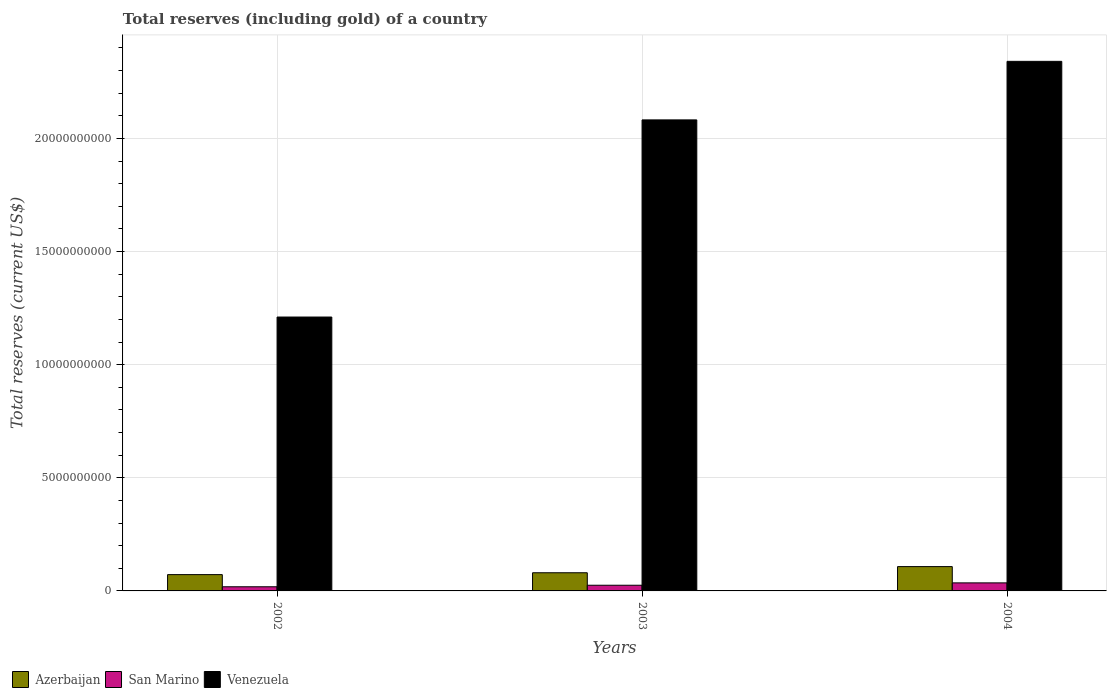How many different coloured bars are there?
Your answer should be very brief. 3. How many groups of bars are there?
Offer a very short reply. 3. Are the number of bars on each tick of the X-axis equal?
Your answer should be compact. Yes. How many bars are there on the 1st tick from the left?
Provide a succinct answer. 3. How many bars are there on the 2nd tick from the right?
Your response must be concise. 3. What is the label of the 3rd group of bars from the left?
Provide a short and direct response. 2004. What is the total reserves (including gold) in Venezuela in 2004?
Your answer should be compact. 2.34e+1. Across all years, what is the maximum total reserves (including gold) in San Marino?
Ensure brevity in your answer.  3.56e+08. Across all years, what is the minimum total reserves (including gold) in Venezuela?
Offer a terse response. 1.21e+1. What is the total total reserves (including gold) in Azerbaijan in the graph?
Provide a succinct answer. 2.60e+09. What is the difference between the total reserves (including gold) in Venezuela in 2002 and that in 2004?
Provide a short and direct response. -1.13e+1. What is the difference between the total reserves (including gold) in Azerbaijan in 2003 and the total reserves (including gold) in San Marino in 2002?
Your answer should be very brief. 6.19e+08. What is the average total reserves (including gold) in San Marino per year?
Offer a terse response. 2.63e+08. In the year 2003, what is the difference between the total reserves (including gold) in Azerbaijan and total reserves (including gold) in Venezuela?
Ensure brevity in your answer.  -2.00e+1. In how many years, is the total reserves (including gold) in Azerbaijan greater than 22000000000 US$?
Keep it short and to the point. 0. What is the ratio of the total reserves (including gold) in San Marino in 2003 to that in 2004?
Keep it short and to the point. 0.71. Is the total reserves (including gold) in Venezuela in 2002 less than that in 2004?
Ensure brevity in your answer.  Yes. Is the difference between the total reserves (including gold) in Azerbaijan in 2002 and 2003 greater than the difference between the total reserves (including gold) in Venezuela in 2002 and 2003?
Offer a very short reply. Yes. What is the difference between the highest and the second highest total reserves (including gold) in Venezuela?
Provide a succinct answer. 2.59e+09. What is the difference between the highest and the lowest total reserves (including gold) in Azerbaijan?
Your answer should be compact. 3.55e+08. In how many years, is the total reserves (including gold) in Venezuela greater than the average total reserves (including gold) in Venezuela taken over all years?
Offer a very short reply. 2. What does the 3rd bar from the left in 2002 represents?
Offer a very short reply. Venezuela. What does the 3rd bar from the right in 2002 represents?
Your answer should be very brief. Azerbaijan. Is it the case that in every year, the sum of the total reserves (including gold) in San Marino and total reserves (including gold) in Azerbaijan is greater than the total reserves (including gold) in Venezuela?
Your answer should be very brief. No. Are all the bars in the graph horizontal?
Provide a short and direct response. No. Are the values on the major ticks of Y-axis written in scientific E-notation?
Ensure brevity in your answer.  No. Does the graph contain any zero values?
Offer a terse response. No. How are the legend labels stacked?
Keep it short and to the point. Horizontal. What is the title of the graph?
Offer a very short reply. Total reserves (including gold) of a country. Does "Japan" appear as one of the legend labels in the graph?
Offer a very short reply. No. What is the label or title of the Y-axis?
Offer a terse response. Total reserves (current US$). What is the Total reserves (current US$) of Azerbaijan in 2002?
Provide a succinct answer. 7.20e+08. What is the Total reserves (current US$) of San Marino in 2002?
Your response must be concise. 1.83e+08. What is the Total reserves (current US$) in Venezuela in 2002?
Provide a succinct answer. 1.21e+1. What is the Total reserves (current US$) in Azerbaijan in 2003?
Offer a very short reply. 8.03e+08. What is the Total reserves (current US$) of San Marino in 2003?
Your answer should be very brief. 2.51e+08. What is the Total reserves (current US$) of Venezuela in 2003?
Your answer should be very brief. 2.08e+1. What is the Total reserves (current US$) in Azerbaijan in 2004?
Offer a very short reply. 1.08e+09. What is the Total reserves (current US$) in San Marino in 2004?
Make the answer very short. 3.56e+08. What is the Total reserves (current US$) in Venezuela in 2004?
Make the answer very short. 2.34e+1. Across all years, what is the maximum Total reserves (current US$) of Azerbaijan?
Keep it short and to the point. 1.08e+09. Across all years, what is the maximum Total reserves (current US$) in San Marino?
Provide a short and direct response. 3.56e+08. Across all years, what is the maximum Total reserves (current US$) of Venezuela?
Offer a very short reply. 2.34e+1. Across all years, what is the minimum Total reserves (current US$) in Azerbaijan?
Give a very brief answer. 7.20e+08. Across all years, what is the minimum Total reserves (current US$) of San Marino?
Your answer should be very brief. 1.83e+08. Across all years, what is the minimum Total reserves (current US$) of Venezuela?
Provide a succinct answer. 1.21e+1. What is the total Total reserves (current US$) of Azerbaijan in the graph?
Provide a short and direct response. 2.60e+09. What is the total Total reserves (current US$) in San Marino in the graph?
Your response must be concise. 7.90e+08. What is the total Total reserves (current US$) of Venezuela in the graph?
Your answer should be compact. 5.63e+1. What is the difference between the Total reserves (current US$) in Azerbaijan in 2002 and that in 2003?
Offer a very short reply. -8.24e+07. What is the difference between the Total reserves (current US$) in San Marino in 2002 and that in 2003?
Keep it short and to the point. -6.79e+07. What is the difference between the Total reserves (current US$) of Venezuela in 2002 and that in 2003?
Your answer should be compact. -8.71e+09. What is the difference between the Total reserves (current US$) in Azerbaijan in 2002 and that in 2004?
Provide a short and direct response. -3.55e+08. What is the difference between the Total reserves (current US$) in San Marino in 2002 and that in 2004?
Your response must be concise. -1.72e+08. What is the difference between the Total reserves (current US$) of Venezuela in 2002 and that in 2004?
Offer a terse response. -1.13e+1. What is the difference between the Total reserves (current US$) in Azerbaijan in 2003 and that in 2004?
Ensure brevity in your answer.  -2.72e+08. What is the difference between the Total reserves (current US$) of San Marino in 2003 and that in 2004?
Your answer should be very brief. -1.04e+08. What is the difference between the Total reserves (current US$) in Venezuela in 2003 and that in 2004?
Make the answer very short. -2.59e+09. What is the difference between the Total reserves (current US$) in Azerbaijan in 2002 and the Total reserves (current US$) in San Marino in 2003?
Ensure brevity in your answer.  4.69e+08. What is the difference between the Total reserves (current US$) of Azerbaijan in 2002 and the Total reserves (current US$) of Venezuela in 2003?
Your response must be concise. -2.01e+1. What is the difference between the Total reserves (current US$) of San Marino in 2002 and the Total reserves (current US$) of Venezuela in 2003?
Give a very brief answer. -2.06e+1. What is the difference between the Total reserves (current US$) of Azerbaijan in 2002 and the Total reserves (current US$) of San Marino in 2004?
Keep it short and to the point. 3.65e+08. What is the difference between the Total reserves (current US$) in Azerbaijan in 2002 and the Total reserves (current US$) in Venezuela in 2004?
Offer a very short reply. -2.27e+1. What is the difference between the Total reserves (current US$) in San Marino in 2002 and the Total reserves (current US$) in Venezuela in 2004?
Offer a very short reply. -2.32e+1. What is the difference between the Total reserves (current US$) in Azerbaijan in 2003 and the Total reserves (current US$) in San Marino in 2004?
Keep it short and to the point. 4.47e+08. What is the difference between the Total reserves (current US$) of Azerbaijan in 2003 and the Total reserves (current US$) of Venezuela in 2004?
Provide a short and direct response. -2.26e+1. What is the difference between the Total reserves (current US$) of San Marino in 2003 and the Total reserves (current US$) of Venezuela in 2004?
Offer a very short reply. -2.32e+1. What is the average Total reserves (current US$) in Azerbaijan per year?
Keep it short and to the point. 8.66e+08. What is the average Total reserves (current US$) of San Marino per year?
Offer a very short reply. 2.63e+08. What is the average Total reserves (current US$) of Venezuela per year?
Your answer should be very brief. 1.88e+1. In the year 2002, what is the difference between the Total reserves (current US$) in Azerbaijan and Total reserves (current US$) in San Marino?
Offer a very short reply. 5.37e+08. In the year 2002, what is the difference between the Total reserves (current US$) of Azerbaijan and Total reserves (current US$) of Venezuela?
Give a very brief answer. -1.14e+1. In the year 2002, what is the difference between the Total reserves (current US$) in San Marino and Total reserves (current US$) in Venezuela?
Provide a succinct answer. -1.19e+1. In the year 2003, what is the difference between the Total reserves (current US$) in Azerbaijan and Total reserves (current US$) in San Marino?
Provide a succinct answer. 5.52e+08. In the year 2003, what is the difference between the Total reserves (current US$) of Azerbaijan and Total reserves (current US$) of Venezuela?
Make the answer very short. -2.00e+1. In the year 2003, what is the difference between the Total reserves (current US$) of San Marino and Total reserves (current US$) of Venezuela?
Make the answer very short. -2.06e+1. In the year 2004, what is the difference between the Total reserves (current US$) in Azerbaijan and Total reserves (current US$) in San Marino?
Make the answer very short. 7.20e+08. In the year 2004, what is the difference between the Total reserves (current US$) in Azerbaijan and Total reserves (current US$) in Venezuela?
Offer a very short reply. -2.23e+1. In the year 2004, what is the difference between the Total reserves (current US$) in San Marino and Total reserves (current US$) in Venezuela?
Ensure brevity in your answer.  -2.31e+1. What is the ratio of the Total reserves (current US$) of Azerbaijan in 2002 to that in 2003?
Ensure brevity in your answer.  0.9. What is the ratio of the Total reserves (current US$) of San Marino in 2002 to that in 2003?
Offer a very short reply. 0.73. What is the ratio of the Total reserves (current US$) in Venezuela in 2002 to that in 2003?
Offer a terse response. 0.58. What is the ratio of the Total reserves (current US$) of Azerbaijan in 2002 to that in 2004?
Make the answer very short. 0.67. What is the ratio of the Total reserves (current US$) in San Marino in 2002 to that in 2004?
Make the answer very short. 0.52. What is the ratio of the Total reserves (current US$) of Venezuela in 2002 to that in 2004?
Provide a succinct answer. 0.52. What is the ratio of the Total reserves (current US$) in Azerbaijan in 2003 to that in 2004?
Your answer should be very brief. 0.75. What is the ratio of the Total reserves (current US$) in San Marino in 2003 to that in 2004?
Give a very brief answer. 0.71. What is the ratio of the Total reserves (current US$) of Venezuela in 2003 to that in 2004?
Offer a terse response. 0.89. What is the difference between the highest and the second highest Total reserves (current US$) of Azerbaijan?
Your answer should be compact. 2.72e+08. What is the difference between the highest and the second highest Total reserves (current US$) in San Marino?
Keep it short and to the point. 1.04e+08. What is the difference between the highest and the second highest Total reserves (current US$) in Venezuela?
Your response must be concise. 2.59e+09. What is the difference between the highest and the lowest Total reserves (current US$) of Azerbaijan?
Your response must be concise. 3.55e+08. What is the difference between the highest and the lowest Total reserves (current US$) of San Marino?
Provide a short and direct response. 1.72e+08. What is the difference between the highest and the lowest Total reserves (current US$) in Venezuela?
Offer a terse response. 1.13e+1. 